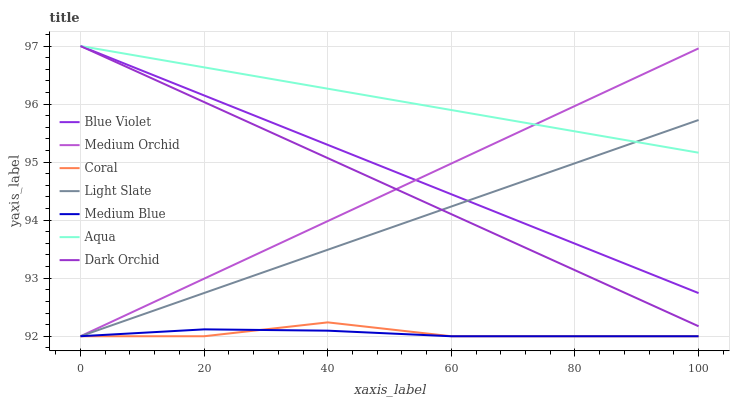Does Medium Blue have the minimum area under the curve?
Answer yes or no. Yes. Does Aqua have the maximum area under the curve?
Answer yes or no. Yes. Does Coral have the minimum area under the curve?
Answer yes or no. No. Does Coral have the maximum area under the curve?
Answer yes or no. No. Is Light Slate the smoothest?
Answer yes or no. Yes. Is Coral the roughest?
Answer yes or no. Yes. Is Medium Blue the smoothest?
Answer yes or no. No. Is Medium Blue the roughest?
Answer yes or no. No. Does Light Slate have the lowest value?
Answer yes or no. Yes. Does Aqua have the lowest value?
Answer yes or no. No. Does Blue Violet have the highest value?
Answer yes or no. Yes. Does Coral have the highest value?
Answer yes or no. No. Is Coral less than Dark Orchid?
Answer yes or no. Yes. Is Dark Orchid greater than Coral?
Answer yes or no. Yes. Does Medium Orchid intersect Light Slate?
Answer yes or no. Yes. Is Medium Orchid less than Light Slate?
Answer yes or no. No. Is Medium Orchid greater than Light Slate?
Answer yes or no. No. Does Coral intersect Dark Orchid?
Answer yes or no. No. 